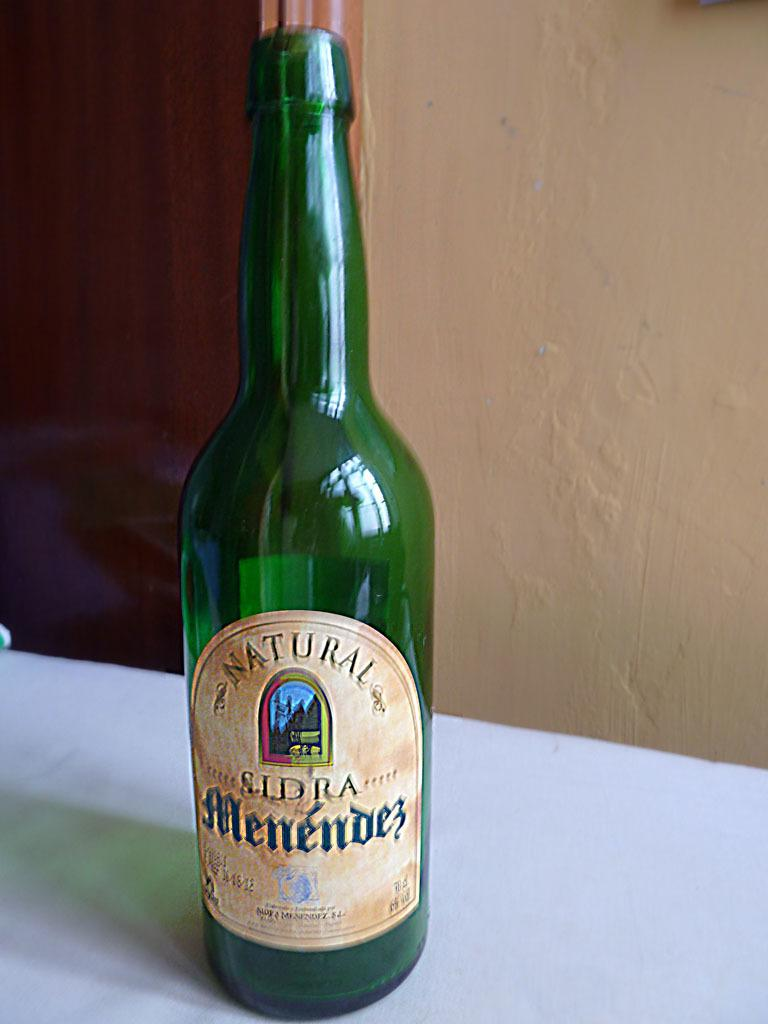Provide a one-sentence caption for the provided image. A beer bottle saying Natural Sldra Menendes that is green. 